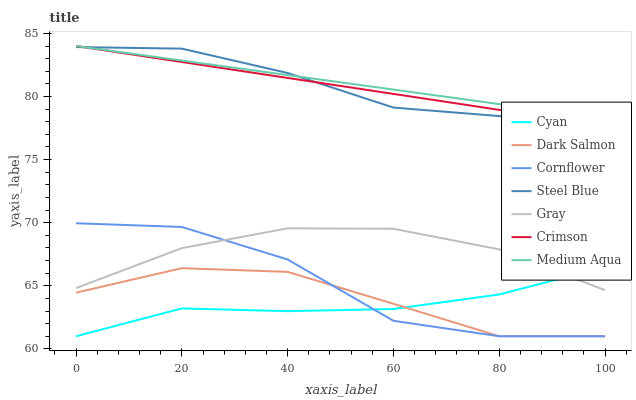Does Cyan have the minimum area under the curve?
Answer yes or no. Yes. Does Medium Aqua have the maximum area under the curve?
Answer yes or no. Yes. Does Cornflower have the minimum area under the curve?
Answer yes or no. No. Does Cornflower have the maximum area under the curve?
Answer yes or no. No. Is Crimson the smoothest?
Answer yes or no. Yes. Is Cornflower the roughest?
Answer yes or no. Yes. Is Steel Blue the smoothest?
Answer yes or no. No. Is Steel Blue the roughest?
Answer yes or no. No. Does Cornflower have the lowest value?
Answer yes or no. Yes. Does Steel Blue have the lowest value?
Answer yes or no. No. Does Crimson have the highest value?
Answer yes or no. Yes. Does Cornflower have the highest value?
Answer yes or no. No. Is Cornflower less than Steel Blue?
Answer yes or no. Yes. Is Medium Aqua greater than Gray?
Answer yes or no. Yes. Does Gray intersect Cyan?
Answer yes or no. Yes. Is Gray less than Cyan?
Answer yes or no. No. Is Gray greater than Cyan?
Answer yes or no. No. Does Cornflower intersect Steel Blue?
Answer yes or no. No. 